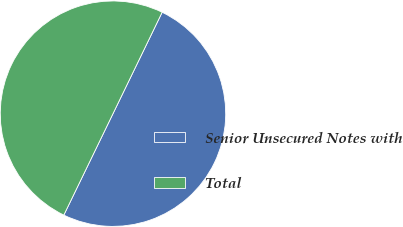<chart> <loc_0><loc_0><loc_500><loc_500><pie_chart><fcel>Senior Unsecured Notes with<fcel>Total<nl><fcel>50.0%<fcel>50.0%<nl></chart> 